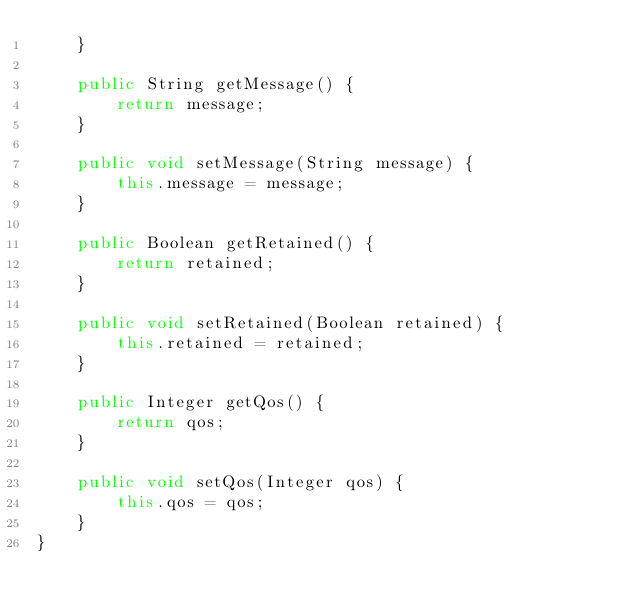<code> <loc_0><loc_0><loc_500><loc_500><_Java_>    }

    public String getMessage() {
        return message;
    }

    public void setMessage(String message) {
        this.message = message;
    }

    public Boolean getRetained() {
        return retained;
    }

    public void setRetained(Boolean retained) {
        this.retained = retained;
    }

    public Integer getQos() {
        return qos;
    }

    public void setQos(Integer qos) {
        this.qos = qos;
    }
}
</code> 